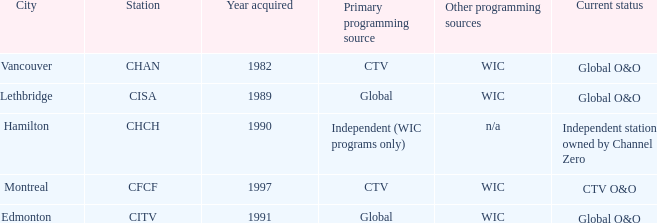Where is citv located Edmonton. 